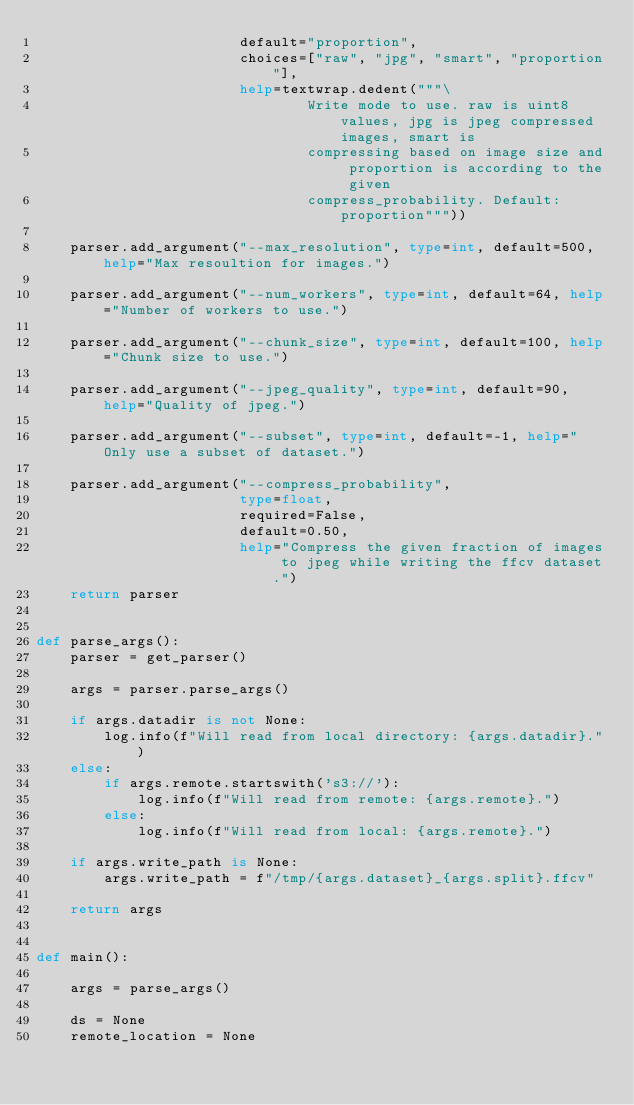Convert code to text. <code><loc_0><loc_0><loc_500><loc_500><_Python_>                        default="proportion",
                        choices=["raw", "jpg", "smart", "proportion"],
                        help=textwrap.dedent("""\
                                Write mode to use. raw is uint8 values, jpg is jpeg compressed images, smart is
                                compressing based on image size and proportion is according to the given
                                compress_probability. Default: proportion"""))

    parser.add_argument("--max_resolution", type=int, default=500, help="Max resoultion for images.")

    parser.add_argument("--num_workers", type=int, default=64, help="Number of workers to use.")

    parser.add_argument("--chunk_size", type=int, default=100, help="Chunk size to use.")

    parser.add_argument("--jpeg_quality", type=int, default=90, help="Quality of jpeg.")

    parser.add_argument("--subset", type=int, default=-1, help="Only use a subset of dataset.")

    parser.add_argument("--compress_probability",
                        type=float,
                        required=False,
                        default=0.50,
                        help="Compress the given fraction of images to jpeg while writing the ffcv dataset.")
    return parser


def parse_args():
    parser = get_parser()

    args = parser.parse_args()

    if args.datadir is not None:
        log.info(f"Will read from local directory: {args.datadir}.")
    else:
        if args.remote.startswith('s3://'):
            log.info(f"Will read from remote: {args.remote}.")
        else:
            log.info(f"Will read from local: {args.remote}.")

    if args.write_path is None:
        args.write_path = f"/tmp/{args.dataset}_{args.split}.ffcv"

    return args


def main():

    args = parse_args()

    ds = None
    remote_location = None</code> 